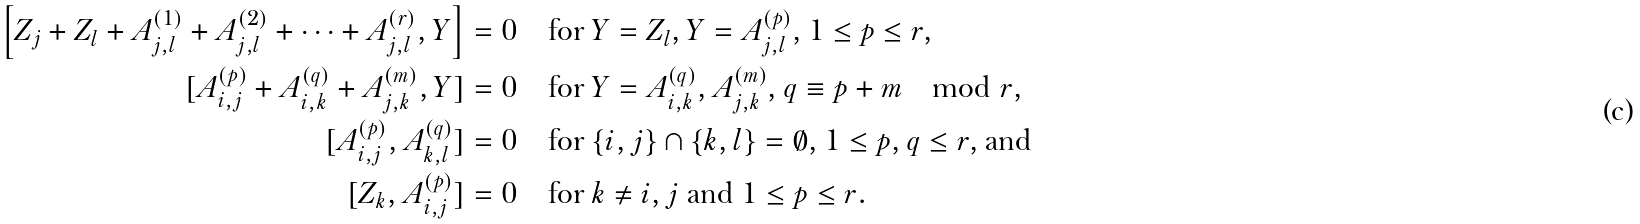<formula> <loc_0><loc_0><loc_500><loc_500>\left [ Z _ { j } + Z _ { l } + A _ { j , l } ^ { ( 1 ) } + A _ { j , l } ^ { ( 2 ) } + \dots + A _ { j , l } ^ { ( r ) } , Y \right ] & = 0 \quad \text {for $Y=Z_{l}$, $Y=A_{j,l}^{(p)}$, $1\leq p\leq r$,} \\ [ A _ { i , j } ^ { ( p ) } + A _ { i , k } ^ { ( q ) } + A _ { j , k } ^ { ( m ) } , Y ] & = 0 \quad \text {for $Y=A_{i,k}^{(q)},A_{j,k}^{(m)}$, $q\equiv p+m \mod r$,} \\ [ A _ { i , j } ^ { ( p ) } , A _ { k , l } ^ { ( q ) } ] & = 0 \quad \text {for $\{i,j\}\cap\{k,l\}=\emptyset$, $1\leq p,q\leq r$, and} \\ [ Z _ { k } , A _ { i , j } ^ { ( p ) } ] & = 0 \quad \text {for $k\neq i,j$ and $1\leq p \leq r$.}</formula> 